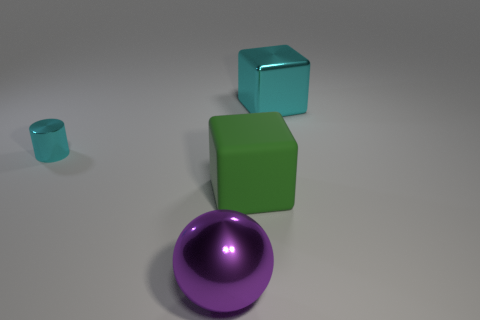Add 1 green matte cubes. How many objects exist? 5 Subtract all cylinders. How many objects are left? 3 Add 1 purple metal balls. How many purple metal balls exist? 2 Subtract all green cubes. How many cubes are left? 1 Subtract 0 yellow balls. How many objects are left? 4 Subtract 1 blocks. How many blocks are left? 1 Subtract all green blocks. Subtract all red balls. How many blocks are left? 1 Subtract all purple spheres. How many cyan cubes are left? 1 Subtract all metal spheres. Subtract all large green things. How many objects are left? 2 Add 3 large green blocks. How many large green blocks are left? 4 